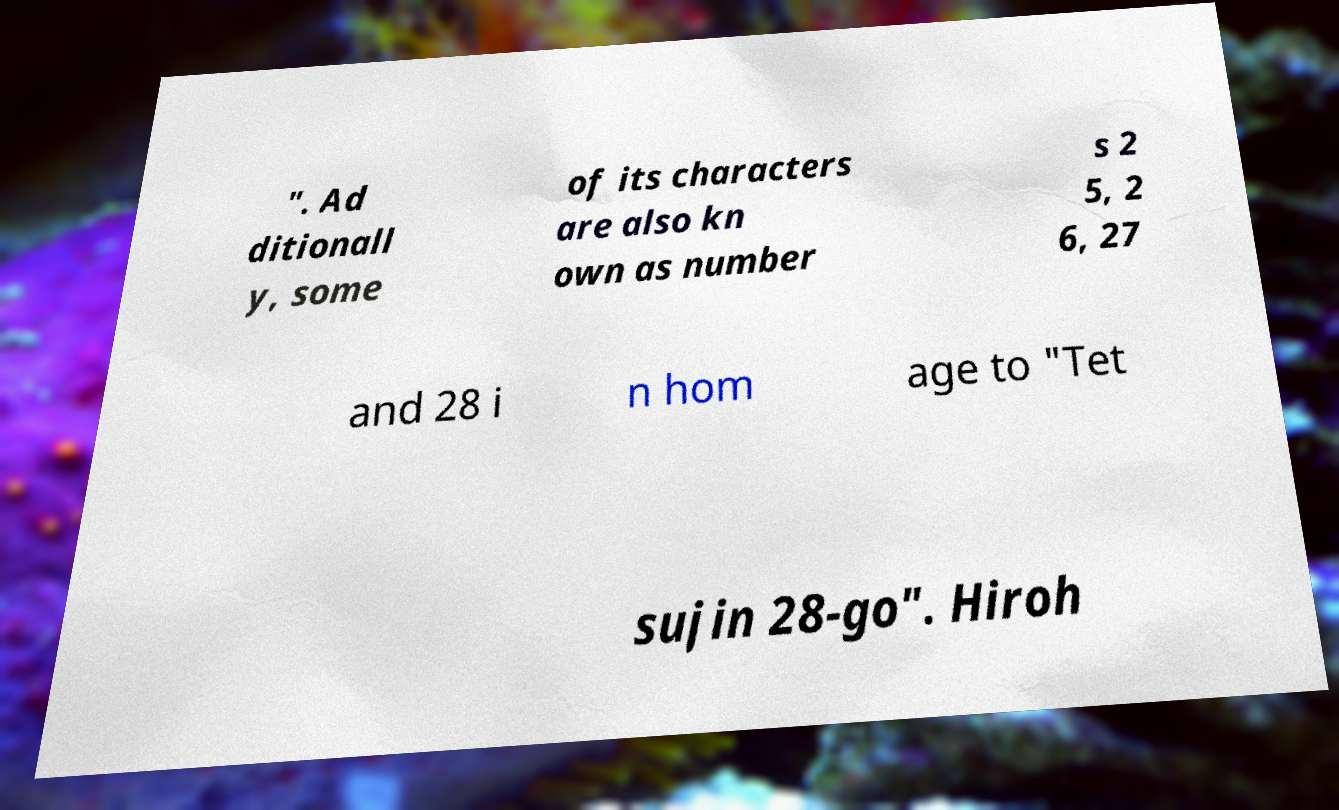Please identify and transcribe the text found in this image. ". Ad ditionall y, some of its characters are also kn own as number s 2 5, 2 6, 27 and 28 i n hom age to "Tet sujin 28-go". Hiroh 